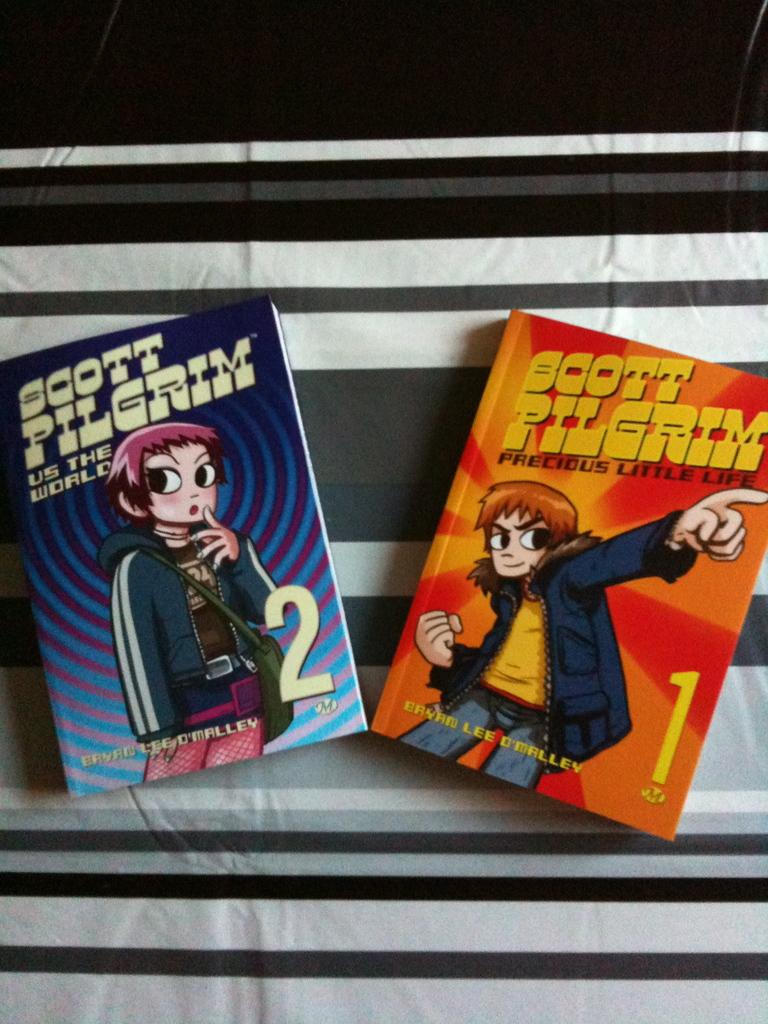<image>
Provide a brief description of the given image. Two books with the title Scott Pilgrim on them. 